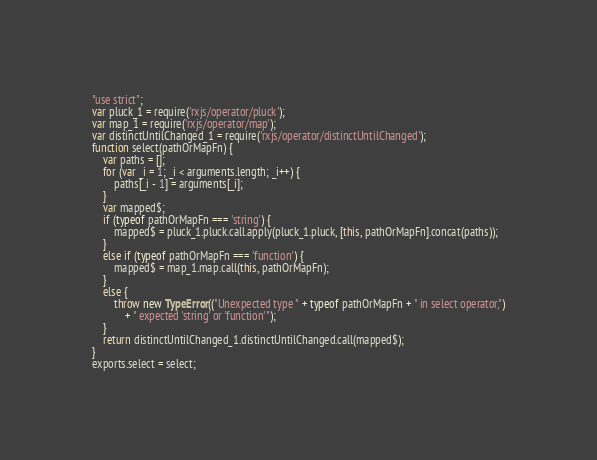Convert code to text. <code><loc_0><loc_0><loc_500><loc_500><_JavaScript_>"use strict";
var pluck_1 = require('rxjs/operator/pluck');
var map_1 = require('rxjs/operator/map');
var distinctUntilChanged_1 = require('rxjs/operator/distinctUntilChanged');
function select(pathOrMapFn) {
    var paths = [];
    for (var _i = 1; _i < arguments.length; _i++) {
        paths[_i - 1] = arguments[_i];
    }
    var mapped$;
    if (typeof pathOrMapFn === 'string') {
        mapped$ = pluck_1.pluck.call.apply(pluck_1.pluck, [this, pathOrMapFn].concat(paths));
    }
    else if (typeof pathOrMapFn === 'function') {
        mapped$ = map_1.map.call(this, pathOrMapFn);
    }
    else {
        throw new TypeError(("Unexpected type " + typeof pathOrMapFn + " in select operator,")
            + " expected 'string' or 'function'");
    }
    return distinctUntilChanged_1.distinctUntilChanged.call(mapped$);
}
exports.select = select;
</code> 